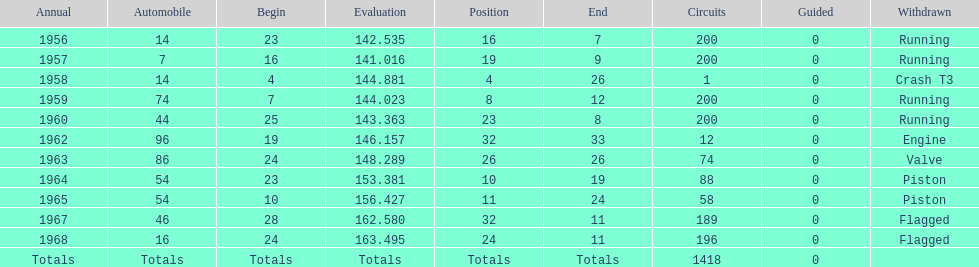Which year is the last qual on the chart 1968. 